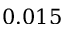<formula> <loc_0><loc_0><loc_500><loc_500>0 . 0 1 5</formula> 